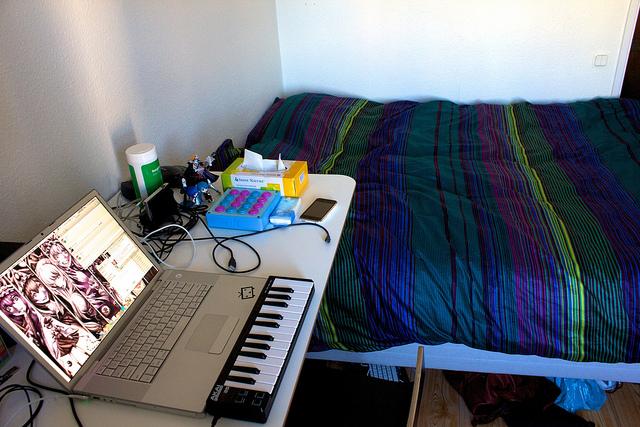Is the desk clean and neat?
Write a very short answer. No. How many anime girls are clearly visible on the computer's desktop?
Quick response, please. 4. Does the bed look comfortable?
Concise answer only. Yes. 